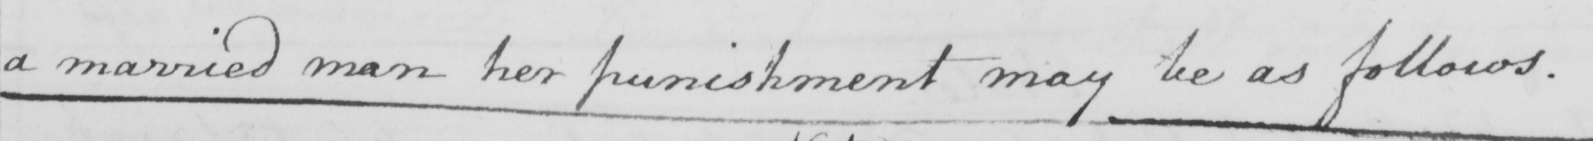What text is written in this handwritten line? a married man her punishment may be as follows . 